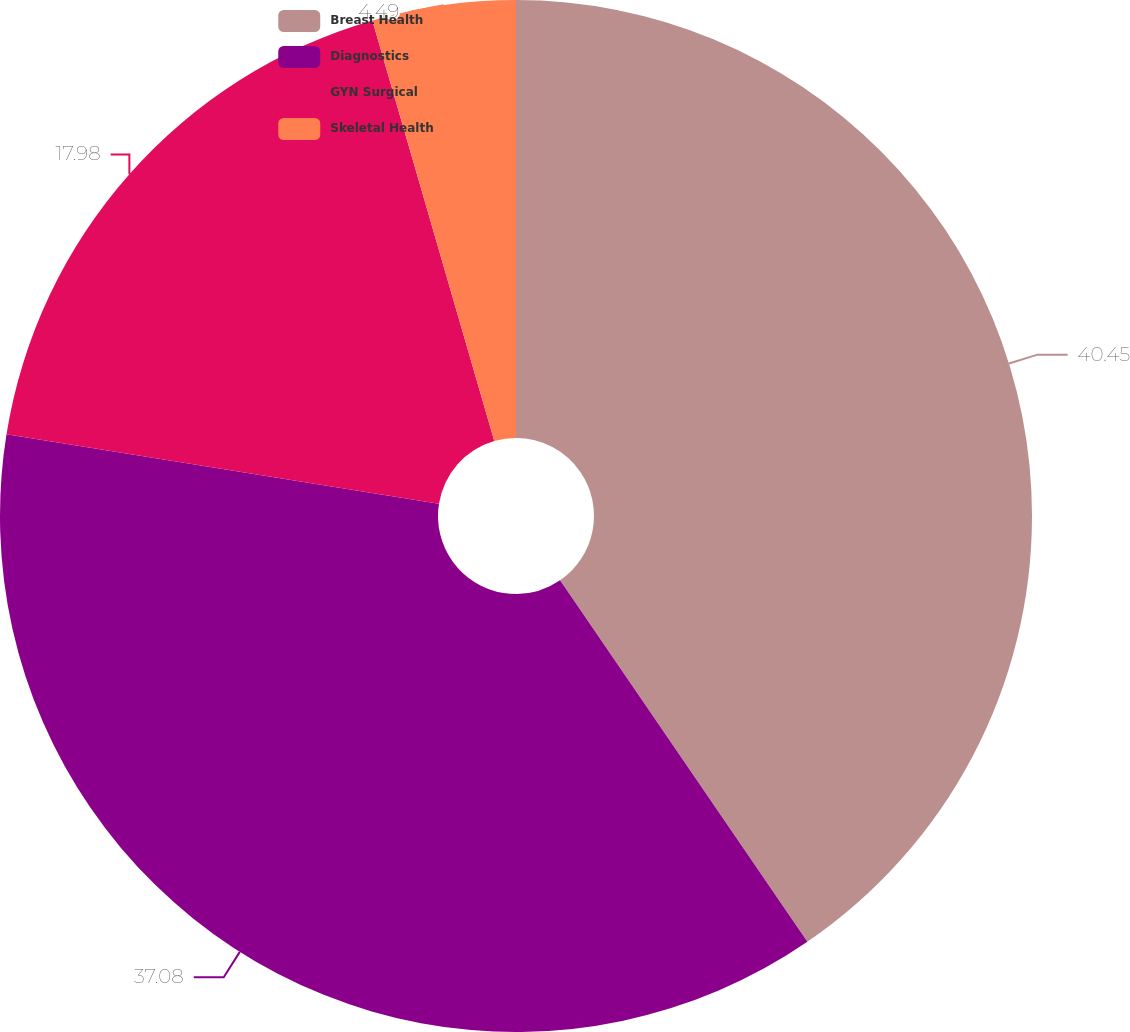<chart> <loc_0><loc_0><loc_500><loc_500><pie_chart><fcel>Breast Health<fcel>Diagnostics<fcel>GYN Surgical<fcel>Skeletal Health<nl><fcel>40.45%<fcel>37.08%<fcel>17.98%<fcel>4.49%<nl></chart> 